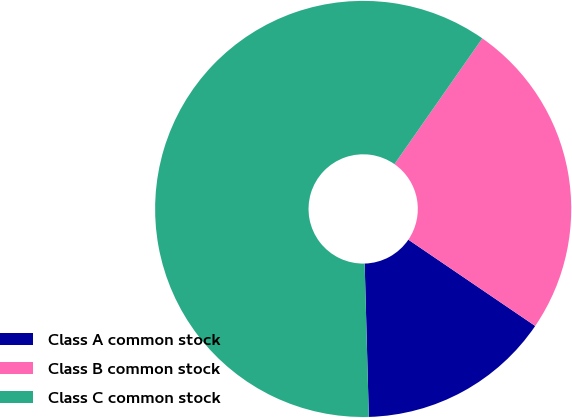Convert chart. <chart><loc_0><loc_0><loc_500><loc_500><pie_chart><fcel>Class A common stock<fcel>Class B common stock<fcel>Class C common stock<nl><fcel>15.06%<fcel>24.8%<fcel>60.13%<nl></chart> 